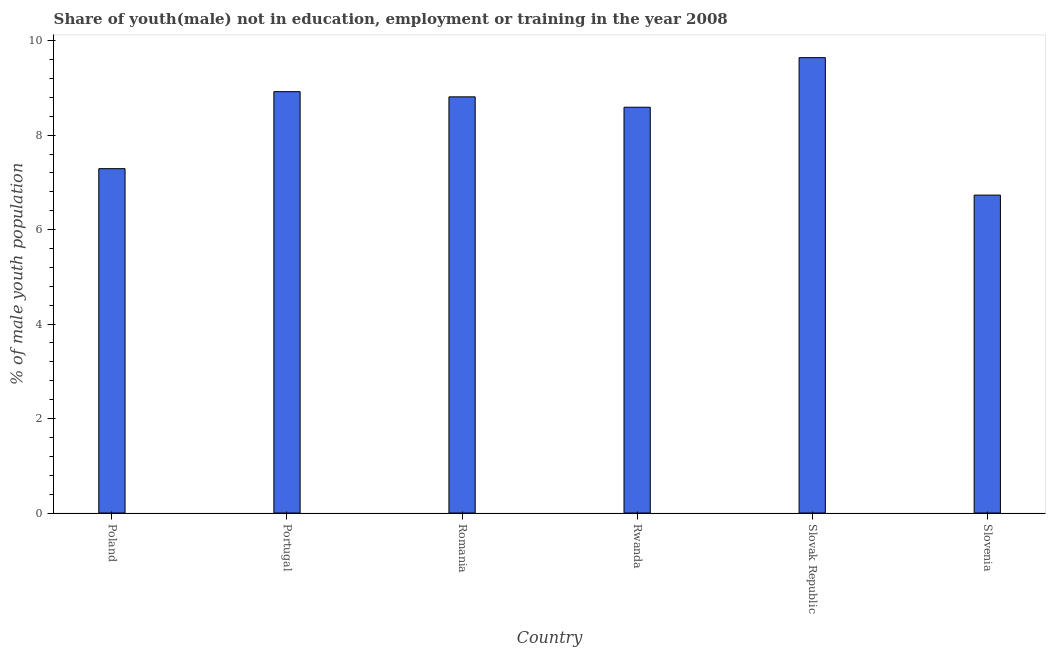What is the title of the graph?
Ensure brevity in your answer.  Share of youth(male) not in education, employment or training in the year 2008. What is the label or title of the Y-axis?
Offer a terse response. % of male youth population. What is the unemployed male youth population in Slovenia?
Your answer should be very brief. 6.73. Across all countries, what is the maximum unemployed male youth population?
Your response must be concise. 9.64. Across all countries, what is the minimum unemployed male youth population?
Your answer should be compact. 6.73. In which country was the unemployed male youth population maximum?
Your answer should be compact. Slovak Republic. In which country was the unemployed male youth population minimum?
Provide a short and direct response. Slovenia. What is the sum of the unemployed male youth population?
Offer a very short reply. 49.98. What is the difference between the unemployed male youth population in Poland and Portugal?
Your answer should be very brief. -1.63. What is the average unemployed male youth population per country?
Ensure brevity in your answer.  8.33. What is the median unemployed male youth population?
Offer a terse response. 8.7. What is the ratio of the unemployed male youth population in Rwanda to that in Slovenia?
Your answer should be compact. 1.28. Is the unemployed male youth population in Poland less than that in Rwanda?
Give a very brief answer. Yes. Is the difference between the unemployed male youth population in Portugal and Slovenia greater than the difference between any two countries?
Provide a succinct answer. No. What is the difference between the highest and the second highest unemployed male youth population?
Provide a succinct answer. 0.72. Is the sum of the unemployed male youth population in Portugal and Romania greater than the maximum unemployed male youth population across all countries?
Provide a succinct answer. Yes. What is the difference between the highest and the lowest unemployed male youth population?
Your response must be concise. 2.91. In how many countries, is the unemployed male youth population greater than the average unemployed male youth population taken over all countries?
Your answer should be compact. 4. What is the difference between two consecutive major ticks on the Y-axis?
Your answer should be very brief. 2. What is the % of male youth population of Poland?
Your answer should be compact. 7.29. What is the % of male youth population of Portugal?
Make the answer very short. 8.92. What is the % of male youth population of Romania?
Give a very brief answer. 8.81. What is the % of male youth population of Rwanda?
Offer a terse response. 8.59. What is the % of male youth population of Slovak Republic?
Offer a very short reply. 9.64. What is the % of male youth population of Slovenia?
Offer a very short reply. 6.73. What is the difference between the % of male youth population in Poland and Portugal?
Offer a very short reply. -1.63. What is the difference between the % of male youth population in Poland and Romania?
Ensure brevity in your answer.  -1.52. What is the difference between the % of male youth population in Poland and Slovak Republic?
Give a very brief answer. -2.35. What is the difference between the % of male youth population in Poland and Slovenia?
Ensure brevity in your answer.  0.56. What is the difference between the % of male youth population in Portugal and Romania?
Offer a very short reply. 0.11. What is the difference between the % of male youth population in Portugal and Rwanda?
Make the answer very short. 0.33. What is the difference between the % of male youth population in Portugal and Slovak Republic?
Your answer should be very brief. -0.72. What is the difference between the % of male youth population in Portugal and Slovenia?
Offer a very short reply. 2.19. What is the difference between the % of male youth population in Romania and Rwanda?
Your response must be concise. 0.22. What is the difference between the % of male youth population in Romania and Slovak Republic?
Make the answer very short. -0.83. What is the difference between the % of male youth population in Romania and Slovenia?
Provide a short and direct response. 2.08. What is the difference between the % of male youth population in Rwanda and Slovak Republic?
Offer a terse response. -1.05. What is the difference between the % of male youth population in Rwanda and Slovenia?
Offer a terse response. 1.86. What is the difference between the % of male youth population in Slovak Republic and Slovenia?
Your answer should be compact. 2.91. What is the ratio of the % of male youth population in Poland to that in Portugal?
Provide a short and direct response. 0.82. What is the ratio of the % of male youth population in Poland to that in Romania?
Keep it short and to the point. 0.83. What is the ratio of the % of male youth population in Poland to that in Rwanda?
Your answer should be compact. 0.85. What is the ratio of the % of male youth population in Poland to that in Slovak Republic?
Your answer should be very brief. 0.76. What is the ratio of the % of male youth population in Poland to that in Slovenia?
Give a very brief answer. 1.08. What is the ratio of the % of male youth population in Portugal to that in Romania?
Make the answer very short. 1.01. What is the ratio of the % of male youth population in Portugal to that in Rwanda?
Keep it short and to the point. 1.04. What is the ratio of the % of male youth population in Portugal to that in Slovak Republic?
Offer a terse response. 0.93. What is the ratio of the % of male youth population in Portugal to that in Slovenia?
Your answer should be very brief. 1.32. What is the ratio of the % of male youth population in Romania to that in Slovak Republic?
Provide a short and direct response. 0.91. What is the ratio of the % of male youth population in Romania to that in Slovenia?
Keep it short and to the point. 1.31. What is the ratio of the % of male youth population in Rwanda to that in Slovak Republic?
Your response must be concise. 0.89. What is the ratio of the % of male youth population in Rwanda to that in Slovenia?
Ensure brevity in your answer.  1.28. What is the ratio of the % of male youth population in Slovak Republic to that in Slovenia?
Your response must be concise. 1.43. 